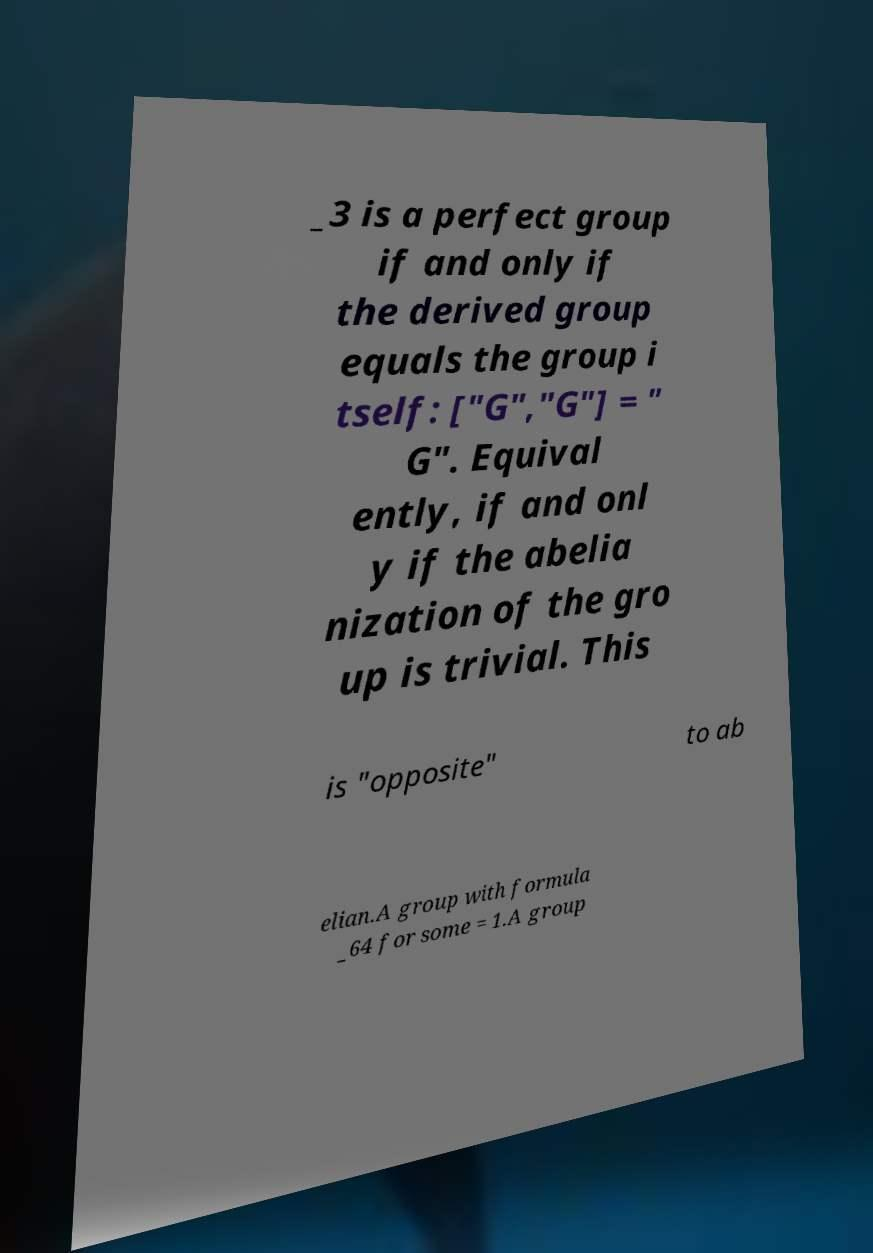Could you extract and type out the text from this image? _3 is a perfect group if and only if the derived group equals the group i tself: ["G","G"] = " G". Equival ently, if and onl y if the abelia nization of the gro up is trivial. This is "opposite" to ab elian.A group with formula _64 for some = 1.A group 